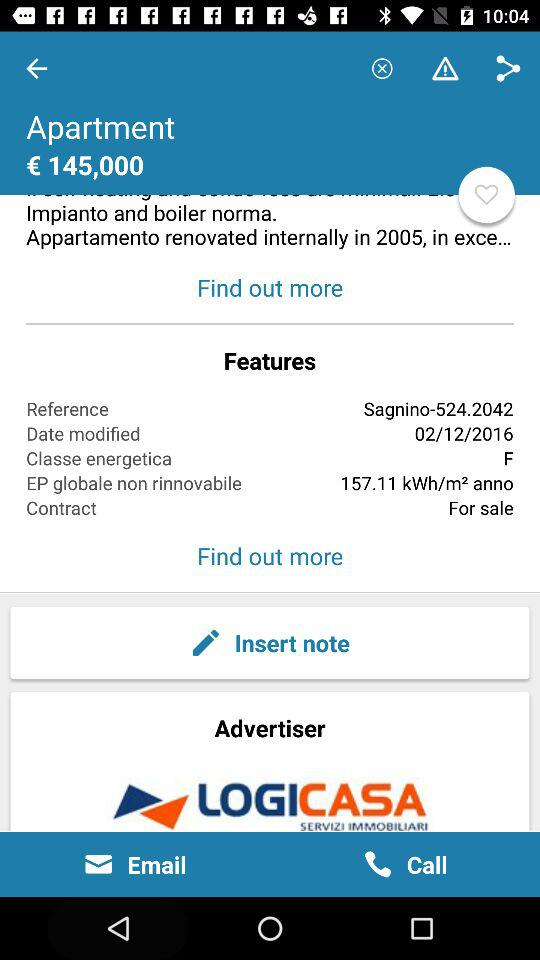How many kWh/m2 anno is the EP globale non rinnovabile?
Answer the question using a single word or phrase. 157.11 